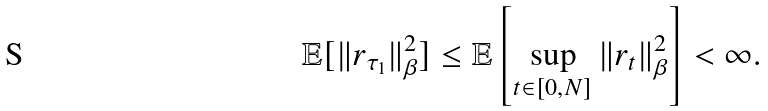<formula> <loc_0><loc_0><loc_500><loc_500>\mathbb { E } [ \| r _ { \tau _ { 1 } } \| _ { \beta } ^ { 2 } ] \leq \mathbb { E } \left [ \sup _ { t \in [ 0 , N ] } \| r _ { t } \| _ { \beta } ^ { 2 } \right ] < \infty .</formula> 